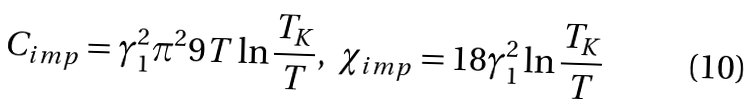Convert formula to latex. <formula><loc_0><loc_0><loc_500><loc_500>C _ { i m p } = \gamma _ { 1 } ^ { 2 } \pi ^ { 2 } 9 T \ln \frac { T _ { K } } { T } , \ \chi _ { i m p } = 1 8 \gamma _ { 1 } ^ { 2 } \ln \frac { T _ { K } } { T }</formula> 